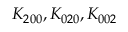Convert formula to latex. <formula><loc_0><loc_0><loc_500><loc_500>K _ { 2 0 0 } , K _ { 0 2 0 } , K _ { 0 0 2 }</formula> 